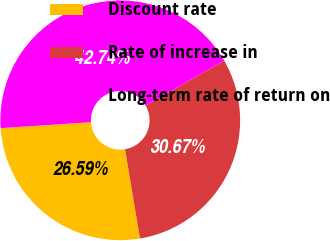Convert chart. <chart><loc_0><loc_0><loc_500><loc_500><pie_chart><fcel>Discount rate<fcel>Rate of increase in<fcel>Long-term rate of return on<nl><fcel>26.59%<fcel>30.67%<fcel>42.74%<nl></chart> 